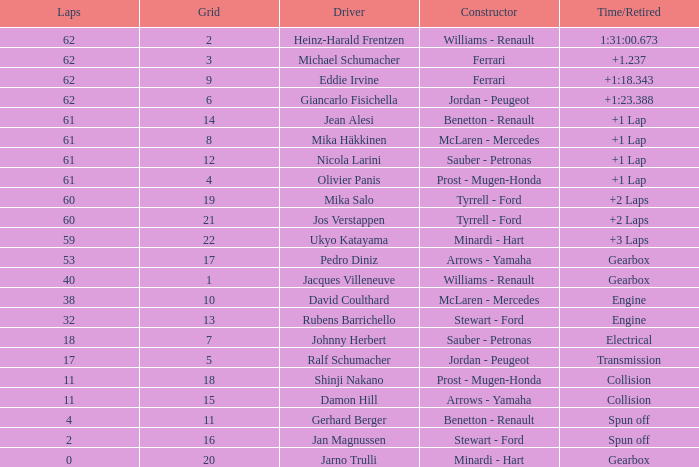What constructor has under 62 laps, a Time/Retired of gearbox, a Grid larger than 1, and pedro diniz driving? Arrows - Yamaha. 